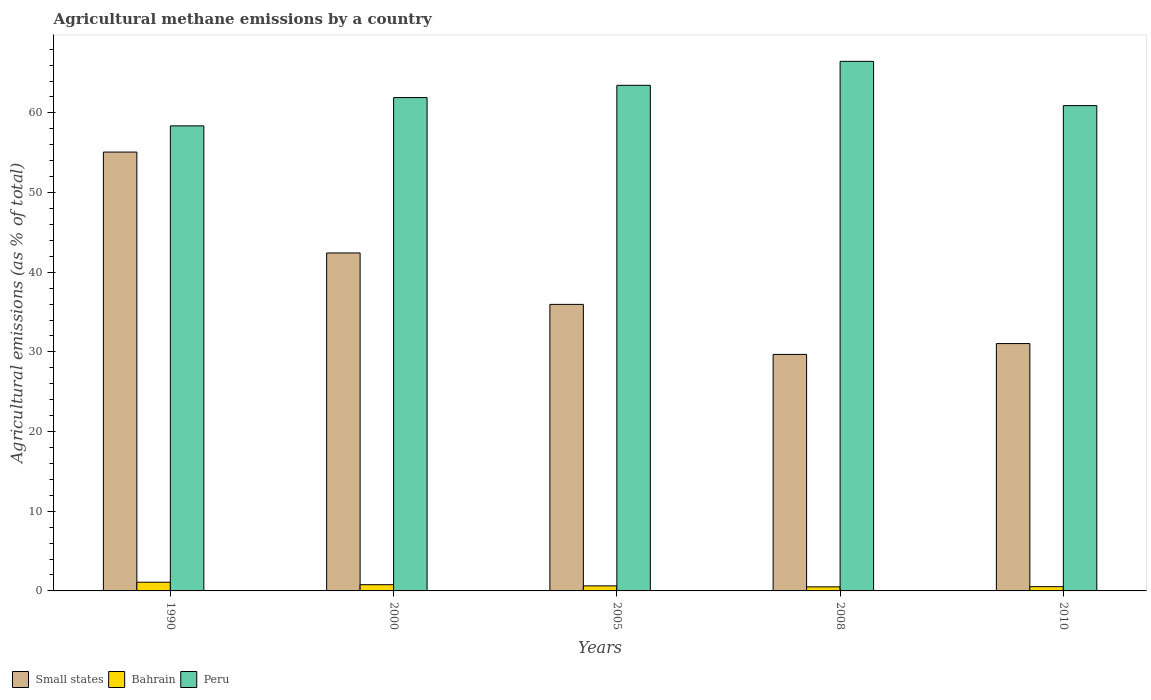In how many cases, is the number of bars for a given year not equal to the number of legend labels?
Your response must be concise. 0. What is the amount of agricultural methane emitted in Small states in 2000?
Your answer should be compact. 42.42. Across all years, what is the maximum amount of agricultural methane emitted in Bahrain?
Provide a succinct answer. 1.09. Across all years, what is the minimum amount of agricultural methane emitted in Peru?
Ensure brevity in your answer.  58.38. In which year was the amount of agricultural methane emitted in Peru minimum?
Your response must be concise. 1990. What is the total amount of agricultural methane emitted in Bahrain in the graph?
Offer a terse response. 3.55. What is the difference between the amount of agricultural methane emitted in Peru in 2005 and that in 2010?
Offer a very short reply. 2.55. What is the difference between the amount of agricultural methane emitted in Peru in 2000 and the amount of agricultural methane emitted in Bahrain in 2005?
Ensure brevity in your answer.  61.29. What is the average amount of agricultural methane emitted in Peru per year?
Your answer should be compact. 62.23. In the year 2000, what is the difference between the amount of agricultural methane emitted in Small states and amount of agricultural methane emitted in Peru?
Provide a short and direct response. -19.5. In how many years, is the amount of agricultural methane emitted in Bahrain greater than 2 %?
Your answer should be compact. 0. What is the ratio of the amount of agricultural methane emitted in Bahrain in 2005 to that in 2010?
Make the answer very short. 1.19. Is the amount of agricultural methane emitted in Peru in 2000 less than that in 2010?
Your response must be concise. No. Is the difference between the amount of agricultural methane emitted in Small states in 2008 and 2010 greater than the difference between the amount of agricultural methane emitted in Peru in 2008 and 2010?
Ensure brevity in your answer.  No. What is the difference between the highest and the second highest amount of agricultural methane emitted in Small states?
Provide a short and direct response. 12.66. What is the difference between the highest and the lowest amount of agricultural methane emitted in Small states?
Your answer should be compact. 25.4. In how many years, is the amount of agricultural methane emitted in Peru greater than the average amount of agricultural methane emitted in Peru taken over all years?
Offer a terse response. 2. Is the sum of the amount of agricultural methane emitted in Bahrain in 2000 and 2010 greater than the maximum amount of agricultural methane emitted in Peru across all years?
Your response must be concise. No. What does the 2nd bar from the left in 1990 represents?
Provide a succinct answer. Bahrain. What does the 1st bar from the right in 2005 represents?
Provide a short and direct response. Peru. How many bars are there?
Keep it short and to the point. 15. Does the graph contain grids?
Provide a short and direct response. No. How many legend labels are there?
Your answer should be compact. 3. How are the legend labels stacked?
Keep it short and to the point. Horizontal. What is the title of the graph?
Offer a very short reply. Agricultural methane emissions by a country. What is the label or title of the Y-axis?
Make the answer very short. Agricultural emissions (as % of total). What is the Agricultural emissions (as % of total) in Small states in 1990?
Give a very brief answer. 55.09. What is the Agricultural emissions (as % of total) in Bahrain in 1990?
Your answer should be compact. 1.09. What is the Agricultural emissions (as % of total) of Peru in 1990?
Offer a very short reply. 58.38. What is the Agricultural emissions (as % of total) of Small states in 2000?
Make the answer very short. 42.42. What is the Agricultural emissions (as % of total) of Bahrain in 2000?
Your answer should be compact. 0.78. What is the Agricultural emissions (as % of total) in Peru in 2000?
Provide a short and direct response. 61.93. What is the Agricultural emissions (as % of total) in Small states in 2005?
Offer a terse response. 35.97. What is the Agricultural emissions (as % of total) of Bahrain in 2005?
Offer a very short reply. 0.63. What is the Agricultural emissions (as % of total) in Peru in 2005?
Give a very brief answer. 63.46. What is the Agricultural emissions (as % of total) of Small states in 2008?
Provide a succinct answer. 29.69. What is the Agricultural emissions (as % of total) in Bahrain in 2008?
Your response must be concise. 0.51. What is the Agricultural emissions (as % of total) in Peru in 2008?
Provide a succinct answer. 66.47. What is the Agricultural emissions (as % of total) in Small states in 2010?
Offer a very short reply. 31.05. What is the Agricultural emissions (as % of total) in Bahrain in 2010?
Offer a very short reply. 0.53. What is the Agricultural emissions (as % of total) in Peru in 2010?
Your answer should be compact. 60.92. Across all years, what is the maximum Agricultural emissions (as % of total) of Small states?
Your response must be concise. 55.09. Across all years, what is the maximum Agricultural emissions (as % of total) in Bahrain?
Provide a short and direct response. 1.09. Across all years, what is the maximum Agricultural emissions (as % of total) in Peru?
Provide a short and direct response. 66.47. Across all years, what is the minimum Agricultural emissions (as % of total) of Small states?
Your response must be concise. 29.69. Across all years, what is the minimum Agricultural emissions (as % of total) in Bahrain?
Your answer should be very brief. 0.51. Across all years, what is the minimum Agricultural emissions (as % of total) of Peru?
Your answer should be very brief. 58.38. What is the total Agricultural emissions (as % of total) of Small states in the graph?
Your response must be concise. 194.21. What is the total Agricultural emissions (as % of total) of Bahrain in the graph?
Offer a very short reply. 3.55. What is the total Agricultural emissions (as % of total) in Peru in the graph?
Offer a terse response. 311.15. What is the difference between the Agricultural emissions (as % of total) of Small states in 1990 and that in 2000?
Make the answer very short. 12.66. What is the difference between the Agricultural emissions (as % of total) of Bahrain in 1990 and that in 2000?
Provide a short and direct response. 0.31. What is the difference between the Agricultural emissions (as % of total) in Peru in 1990 and that in 2000?
Make the answer very short. -3.55. What is the difference between the Agricultural emissions (as % of total) in Small states in 1990 and that in 2005?
Give a very brief answer. 19.12. What is the difference between the Agricultural emissions (as % of total) of Bahrain in 1990 and that in 2005?
Provide a succinct answer. 0.46. What is the difference between the Agricultural emissions (as % of total) of Peru in 1990 and that in 2005?
Offer a very short reply. -5.09. What is the difference between the Agricultural emissions (as % of total) of Small states in 1990 and that in 2008?
Keep it short and to the point. 25.4. What is the difference between the Agricultural emissions (as % of total) of Bahrain in 1990 and that in 2008?
Give a very brief answer. 0.58. What is the difference between the Agricultural emissions (as % of total) in Peru in 1990 and that in 2008?
Offer a very short reply. -8.1. What is the difference between the Agricultural emissions (as % of total) of Small states in 1990 and that in 2010?
Give a very brief answer. 24.04. What is the difference between the Agricultural emissions (as % of total) in Bahrain in 1990 and that in 2010?
Provide a short and direct response. 0.56. What is the difference between the Agricultural emissions (as % of total) of Peru in 1990 and that in 2010?
Give a very brief answer. -2.54. What is the difference between the Agricultural emissions (as % of total) in Small states in 2000 and that in 2005?
Your answer should be compact. 6.45. What is the difference between the Agricultural emissions (as % of total) of Bahrain in 2000 and that in 2005?
Your answer should be very brief. 0.15. What is the difference between the Agricultural emissions (as % of total) of Peru in 2000 and that in 2005?
Give a very brief answer. -1.54. What is the difference between the Agricultural emissions (as % of total) of Small states in 2000 and that in 2008?
Give a very brief answer. 12.73. What is the difference between the Agricultural emissions (as % of total) of Bahrain in 2000 and that in 2008?
Ensure brevity in your answer.  0.27. What is the difference between the Agricultural emissions (as % of total) in Peru in 2000 and that in 2008?
Give a very brief answer. -4.55. What is the difference between the Agricultural emissions (as % of total) in Small states in 2000 and that in 2010?
Your response must be concise. 11.37. What is the difference between the Agricultural emissions (as % of total) of Bahrain in 2000 and that in 2010?
Your answer should be very brief. 0.25. What is the difference between the Agricultural emissions (as % of total) in Peru in 2000 and that in 2010?
Your answer should be very brief. 1.01. What is the difference between the Agricultural emissions (as % of total) of Small states in 2005 and that in 2008?
Keep it short and to the point. 6.28. What is the difference between the Agricultural emissions (as % of total) of Bahrain in 2005 and that in 2008?
Your response must be concise. 0.12. What is the difference between the Agricultural emissions (as % of total) of Peru in 2005 and that in 2008?
Provide a short and direct response. -3.01. What is the difference between the Agricultural emissions (as % of total) in Small states in 2005 and that in 2010?
Ensure brevity in your answer.  4.92. What is the difference between the Agricultural emissions (as % of total) in Bahrain in 2005 and that in 2010?
Your answer should be compact. 0.1. What is the difference between the Agricultural emissions (as % of total) in Peru in 2005 and that in 2010?
Offer a terse response. 2.55. What is the difference between the Agricultural emissions (as % of total) of Small states in 2008 and that in 2010?
Your answer should be very brief. -1.36. What is the difference between the Agricultural emissions (as % of total) in Bahrain in 2008 and that in 2010?
Give a very brief answer. -0.02. What is the difference between the Agricultural emissions (as % of total) in Peru in 2008 and that in 2010?
Offer a very short reply. 5.56. What is the difference between the Agricultural emissions (as % of total) in Small states in 1990 and the Agricultural emissions (as % of total) in Bahrain in 2000?
Provide a short and direct response. 54.3. What is the difference between the Agricultural emissions (as % of total) of Small states in 1990 and the Agricultural emissions (as % of total) of Peru in 2000?
Your response must be concise. -6.84. What is the difference between the Agricultural emissions (as % of total) in Bahrain in 1990 and the Agricultural emissions (as % of total) in Peru in 2000?
Provide a succinct answer. -60.83. What is the difference between the Agricultural emissions (as % of total) of Small states in 1990 and the Agricultural emissions (as % of total) of Bahrain in 2005?
Your response must be concise. 54.45. What is the difference between the Agricultural emissions (as % of total) in Small states in 1990 and the Agricultural emissions (as % of total) in Peru in 2005?
Make the answer very short. -8.38. What is the difference between the Agricultural emissions (as % of total) of Bahrain in 1990 and the Agricultural emissions (as % of total) of Peru in 2005?
Keep it short and to the point. -62.37. What is the difference between the Agricultural emissions (as % of total) of Small states in 1990 and the Agricultural emissions (as % of total) of Bahrain in 2008?
Make the answer very short. 54.58. What is the difference between the Agricultural emissions (as % of total) in Small states in 1990 and the Agricultural emissions (as % of total) in Peru in 2008?
Provide a short and direct response. -11.39. What is the difference between the Agricultural emissions (as % of total) of Bahrain in 1990 and the Agricultural emissions (as % of total) of Peru in 2008?
Offer a very short reply. -65.38. What is the difference between the Agricultural emissions (as % of total) of Small states in 1990 and the Agricultural emissions (as % of total) of Bahrain in 2010?
Ensure brevity in your answer.  54.55. What is the difference between the Agricultural emissions (as % of total) in Small states in 1990 and the Agricultural emissions (as % of total) in Peru in 2010?
Your answer should be very brief. -5.83. What is the difference between the Agricultural emissions (as % of total) of Bahrain in 1990 and the Agricultural emissions (as % of total) of Peru in 2010?
Provide a succinct answer. -59.82. What is the difference between the Agricultural emissions (as % of total) of Small states in 2000 and the Agricultural emissions (as % of total) of Bahrain in 2005?
Ensure brevity in your answer.  41.79. What is the difference between the Agricultural emissions (as % of total) in Small states in 2000 and the Agricultural emissions (as % of total) in Peru in 2005?
Provide a short and direct response. -21.04. What is the difference between the Agricultural emissions (as % of total) of Bahrain in 2000 and the Agricultural emissions (as % of total) of Peru in 2005?
Offer a terse response. -62.68. What is the difference between the Agricultural emissions (as % of total) in Small states in 2000 and the Agricultural emissions (as % of total) in Bahrain in 2008?
Give a very brief answer. 41.91. What is the difference between the Agricultural emissions (as % of total) of Small states in 2000 and the Agricultural emissions (as % of total) of Peru in 2008?
Make the answer very short. -24.05. What is the difference between the Agricultural emissions (as % of total) in Bahrain in 2000 and the Agricultural emissions (as % of total) in Peru in 2008?
Provide a succinct answer. -65.69. What is the difference between the Agricultural emissions (as % of total) of Small states in 2000 and the Agricultural emissions (as % of total) of Bahrain in 2010?
Provide a short and direct response. 41.89. What is the difference between the Agricultural emissions (as % of total) in Small states in 2000 and the Agricultural emissions (as % of total) in Peru in 2010?
Keep it short and to the point. -18.49. What is the difference between the Agricultural emissions (as % of total) in Bahrain in 2000 and the Agricultural emissions (as % of total) in Peru in 2010?
Offer a terse response. -60.13. What is the difference between the Agricultural emissions (as % of total) of Small states in 2005 and the Agricultural emissions (as % of total) of Bahrain in 2008?
Your response must be concise. 35.46. What is the difference between the Agricultural emissions (as % of total) of Small states in 2005 and the Agricultural emissions (as % of total) of Peru in 2008?
Offer a very short reply. -30.51. What is the difference between the Agricultural emissions (as % of total) in Bahrain in 2005 and the Agricultural emissions (as % of total) in Peru in 2008?
Offer a very short reply. -65.84. What is the difference between the Agricultural emissions (as % of total) in Small states in 2005 and the Agricultural emissions (as % of total) in Bahrain in 2010?
Keep it short and to the point. 35.43. What is the difference between the Agricultural emissions (as % of total) in Small states in 2005 and the Agricultural emissions (as % of total) in Peru in 2010?
Provide a short and direct response. -24.95. What is the difference between the Agricultural emissions (as % of total) of Bahrain in 2005 and the Agricultural emissions (as % of total) of Peru in 2010?
Give a very brief answer. -60.28. What is the difference between the Agricultural emissions (as % of total) of Small states in 2008 and the Agricultural emissions (as % of total) of Bahrain in 2010?
Provide a short and direct response. 29.15. What is the difference between the Agricultural emissions (as % of total) in Small states in 2008 and the Agricultural emissions (as % of total) in Peru in 2010?
Keep it short and to the point. -31.23. What is the difference between the Agricultural emissions (as % of total) of Bahrain in 2008 and the Agricultural emissions (as % of total) of Peru in 2010?
Your response must be concise. -60.41. What is the average Agricultural emissions (as % of total) of Small states per year?
Your response must be concise. 38.84. What is the average Agricultural emissions (as % of total) of Bahrain per year?
Offer a terse response. 0.71. What is the average Agricultural emissions (as % of total) of Peru per year?
Offer a terse response. 62.23. In the year 1990, what is the difference between the Agricultural emissions (as % of total) of Small states and Agricultural emissions (as % of total) of Bahrain?
Offer a terse response. 53.99. In the year 1990, what is the difference between the Agricultural emissions (as % of total) of Small states and Agricultural emissions (as % of total) of Peru?
Your answer should be very brief. -3.29. In the year 1990, what is the difference between the Agricultural emissions (as % of total) in Bahrain and Agricultural emissions (as % of total) in Peru?
Your answer should be compact. -57.28. In the year 2000, what is the difference between the Agricultural emissions (as % of total) in Small states and Agricultural emissions (as % of total) in Bahrain?
Make the answer very short. 41.64. In the year 2000, what is the difference between the Agricultural emissions (as % of total) of Small states and Agricultural emissions (as % of total) of Peru?
Your response must be concise. -19.5. In the year 2000, what is the difference between the Agricultural emissions (as % of total) of Bahrain and Agricultural emissions (as % of total) of Peru?
Your response must be concise. -61.14. In the year 2005, what is the difference between the Agricultural emissions (as % of total) of Small states and Agricultural emissions (as % of total) of Bahrain?
Your answer should be very brief. 35.33. In the year 2005, what is the difference between the Agricultural emissions (as % of total) in Small states and Agricultural emissions (as % of total) in Peru?
Your response must be concise. -27.5. In the year 2005, what is the difference between the Agricultural emissions (as % of total) in Bahrain and Agricultural emissions (as % of total) in Peru?
Provide a succinct answer. -62.83. In the year 2008, what is the difference between the Agricultural emissions (as % of total) in Small states and Agricultural emissions (as % of total) in Bahrain?
Provide a succinct answer. 29.18. In the year 2008, what is the difference between the Agricultural emissions (as % of total) in Small states and Agricultural emissions (as % of total) in Peru?
Provide a succinct answer. -36.78. In the year 2008, what is the difference between the Agricultural emissions (as % of total) of Bahrain and Agricultural emissions (as % of total) of Peru?
Offer a terse response. -65.96. In the year 2010, what is the difference between the Agricultural emissions (as % of total) of Small states and Agricultural emissions (as % of total) of Bahrain?
Your answer should be very brief. 30.51. In the year 2010, what is the difference between the Agricultural emissions (as % of total) of Small states and Agricultural emissions (as % of total) of Peru?
Give a very brief answer. -29.87. In the year 2010, what is the difference between the Agricultural emissions (as % of total) of Bahrain and Agricultural emissions (as % of total) of Peru?
Your response must be concise. -60.38. What is the ratio of the Agricultural emissions (as % of total) of Small states in 1990 to that in 2000?
Give a very brief answer. 1.3. What is the ratio of the Agricultural emissions (as % of total) of Bahrain in 1990 to that in 2000?
Make the answer very short. 1.4. What is the ratio of the Agricultural emissions (as % of total) of Peru in 1990 to that in 2000?
Ensure brevity in your answer.  0.94. What is the ratio of the Agricultural emissions (as % of total) of Small states in 1990 to that in 2005?
Ensure brevity in your answer.  1.53. What is the ratio of the Agricultural emissions (as % of total) in Bahrain in 1990 to that in 2005?
Make the answer very short. 1.72. What is the ratio of the Agricultural emissions (as % of total) in Peru in 1990 to that in 2005?
Provide a short and direct response. 0.92. What is the ratio of the Agricultural emissions (as % of total) of Small states in 1990 to that in 2008?
Offer a very short reply. 1.86. What is the ratio of the Agricultural emissions (as % of total) in Bahrain in 1990 to that in 2008?
Make the answer very short. 2.14. What is the ratio of the Agricultural emissions (as % of total) in Peru in 1990 to that in 2008?
Provide a short and direct response. 0.88. What is the ratio of the Agricultural emissions (as % of total) of Small states in 1990 to that in 2010?
Your answer should be compact. 1.77. What is the ratio of the Agricultural emissions (as % of total) in Bahrain in 1990 to that in 2010?
Your answer should be compact. 2.04. What is the ratio of the Agricultural emissions (as % of total) of Peru in 1990 to that in 2010?
Offer a terse response. 0.96. What is the ratio of the Agricultural emissions (as % of total) in Small states in 2000 to that in 2005?
Make the answer very short. 1.18. What is the ratio of the Agricultural emissions (as % of total) in Bahrain in 2000 to that in 2005?
Ensure brevity in your answer.  1.23. What is the ratio of the Agricultural emissions (as % of total) in Peru in 2000 to that in 2005?
Your answer should be very brief. 0.98. What is the ratio of the Agricultural emissions (as % of total) of Small states in 2000 to that in 2008?
Make the answer very short. 1.43. What is the ratio of the Agricultural emissions (as % of total) in Bahrain in 2000 to that in 2008?
Offer a terse response. 1.53. What is the ratio of the Agricultural emissions (as % of total) of Peru in 2000 to that in 2008?
Provide a succinct answer. 0.93. What is the ratio of the Agricultural emissions (as % of total) in Small states in 2000 to that in 2010?
Provide a succinct answer. 1.37. What is the ratio of the Agricultural emissions (as % of total) in Bahrain in 2000 to that in 2010?
Your response must be concise. 1.46. What is the ratio of the Agricultural emissions (as % of total) in Peru in 2000 to that in 2010?
Offer a terse response. 1.02. What is the ratio of the Agricultural emissions (as % of total) in Small states in 2005 to that in 2008?
Provide a succinct answer. 1.21. What is the ratio of the Agricultural emissions (as % of total) of Bahrain in 2005 to that in 2008?
Make the answer very short. 1.24. What is the ratio of the Agricultural emissions (as % of total) of Peru in 2005 to that in 2008?
Your answer should be compact. 0.95. What is the ratio of the Agricultural emissions (as % of total) of Small states in 2005 to that in 2010?
Give a very brief answer. 1.16. What is the ratio of the Agricultural emissions (as % of total) in Bahrain in 2005 to that in 2010?
Make the answer very short. 1.19. What is the ratio of the Agricultural emissions (as % of total) in Peru in 2005 to that in 2010?
Provide a succinct answer. 1.04. What is the ratio of the Agricultural emissions (as % of total) of Small states in 2008 to that in 2010?
Offer a terse response. 0.96. What is the ratio of the Agricultural emissions (as % of total) in Bahrain in 2008 to that in 2010?
Offer a terse response. 0.95. What is the ratio of the Agricultural emissions (as % of total) in Peru in 2008 to that in 2010?
Make the answer very short. 1.09. What is the difference between the highest and the second highest Agricultural emissions (as % of total) in Small states?
Your answer should be compact. 12.66. What is the difference between the highest and the second highest Agricultural emissions (as % of total) in Bahrain?
Your answer should be very brief. 0.31. What is the difference between the highest and the second highest Agricultural emissions (as % of total) in Peru?
Your answer should be very brief. 3.01. What is the difference between the highest and the lowest Agricultural emissions (as % of total) in Small states?
Give a very brief answer. 25.4. What is the difference between the highest and the lowest Agricultural emissions (as % of total) in Bahrain?
Make the answer very short. 0.58. What is the difference between the highest and the lowest Agricultural emissions (as % of total) of Peru?
Provide a succinct answer. 8.1. 